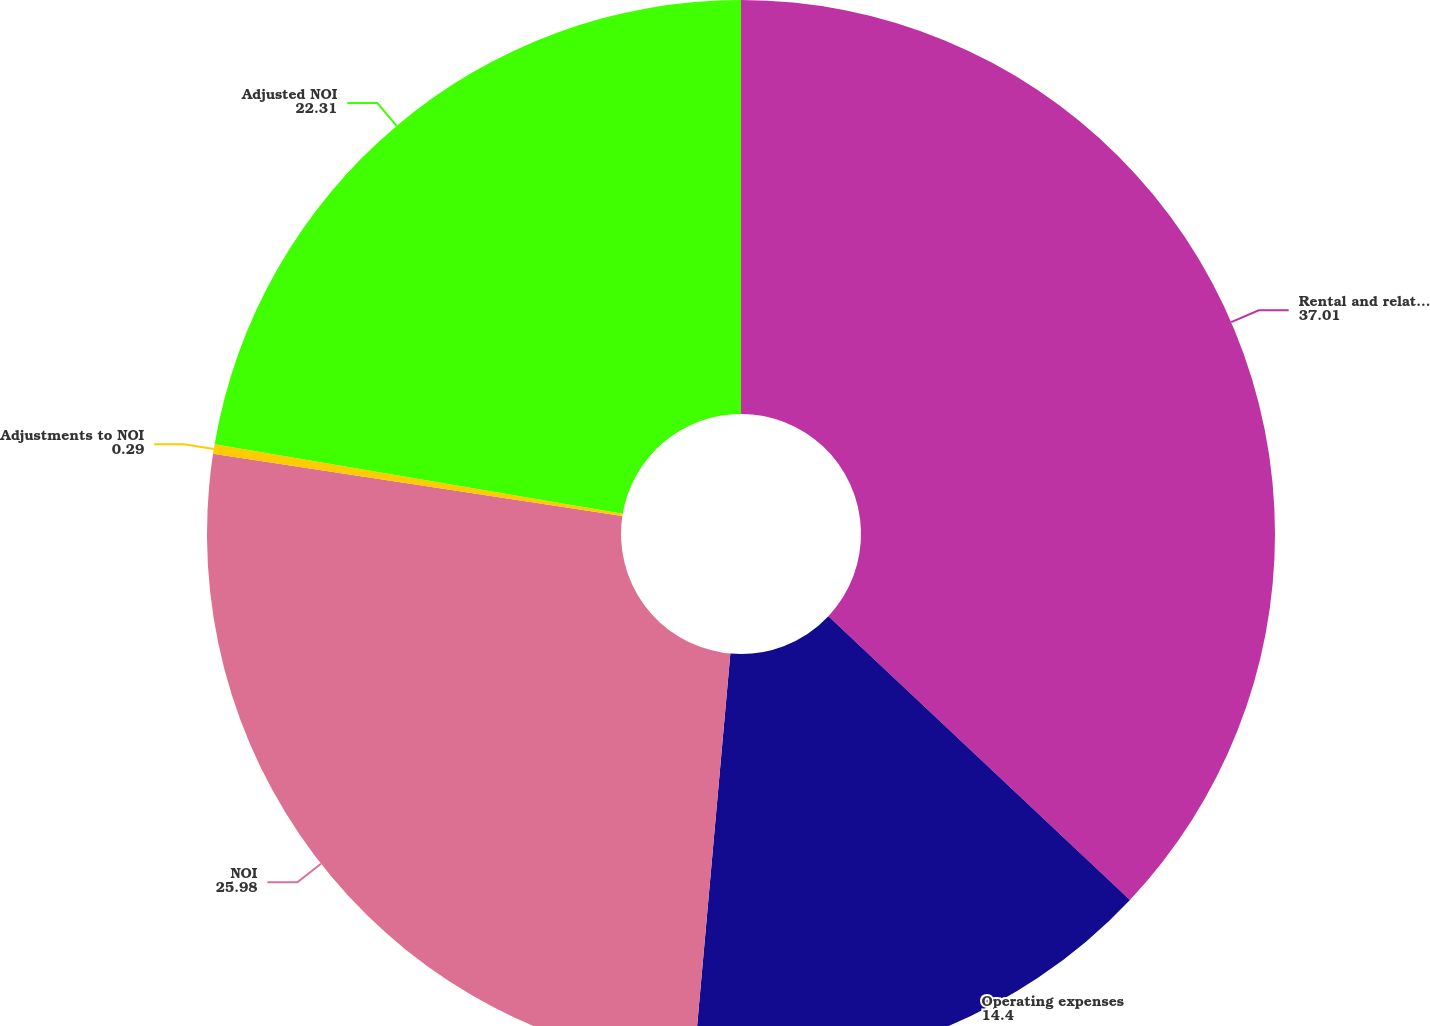<chart> <loc_0><loc_0><loc_500><loc_500><pie_chart><fcel>Rental and related revenues<fcel>Operating expenses<fcel>NOI<fcel>Adjustments to NOI<fcel>Adjusted NOI<nl><fcel>37.01%<fcel>14.4%<fcel>25.98%<fcel>0.29%<fcel>22.31%<nl></chart> 